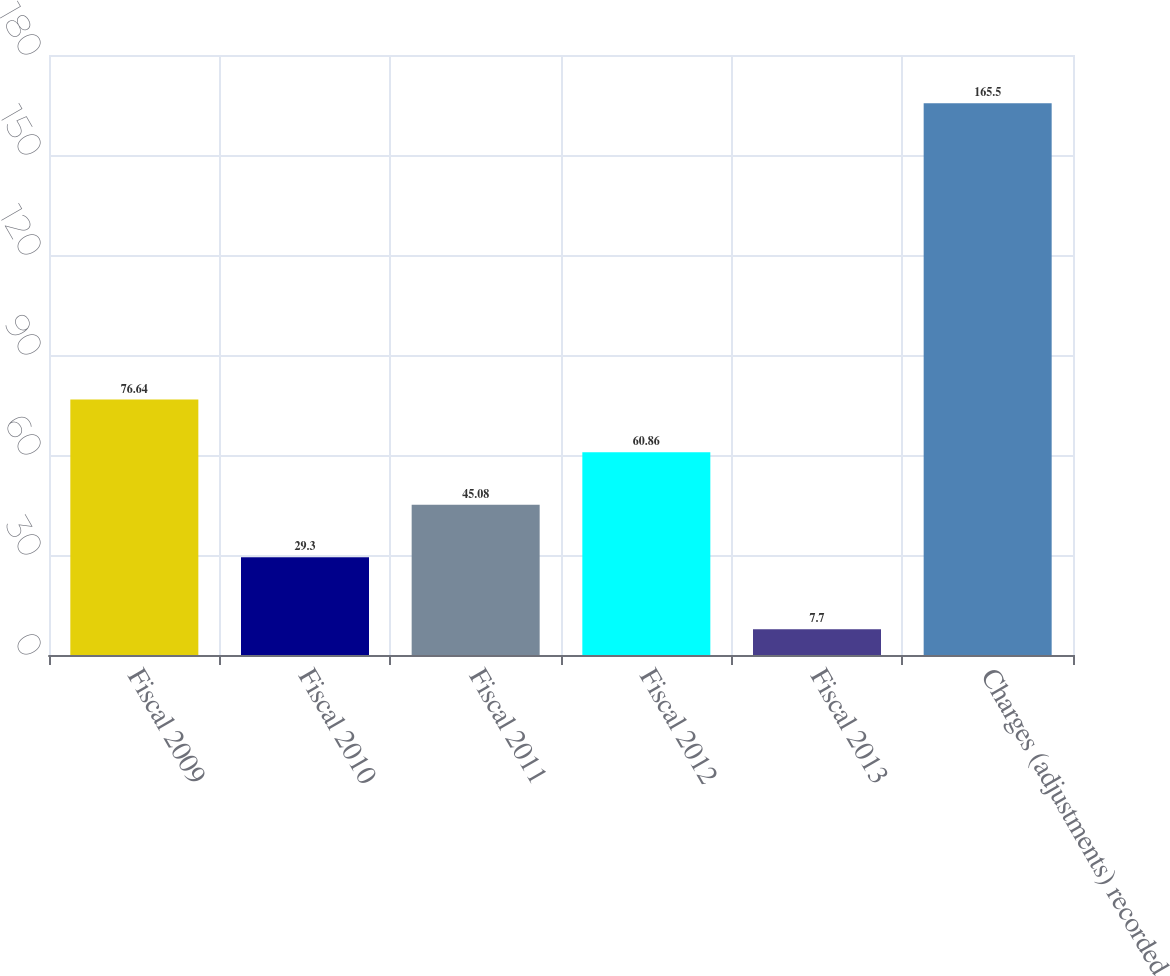Convert chart. <chart><loc_0><loc_0><loc_500><loc_500><bar_chart><fcel>Fiscal 2009<fcel>Fiscal 2010<fcel>Fiscal 2011<fcel>Fiscal 2012<fcel>Fiscal 2013<fcel>Charges (adjustments) recorded<nl><fcel>76.64<fcel>29.3<fcel>45.08<fcel>60.86<fcel>7.7<fcel>165.5<nl></chart> 